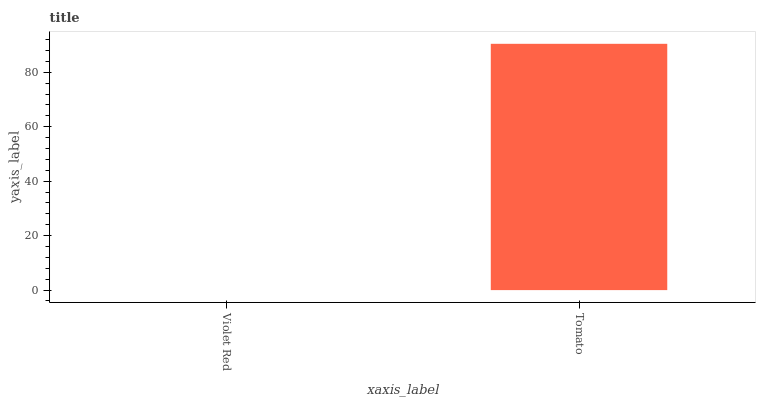Is Violet Red the minimum?
Answer yes or no. Yes. Is Tomato the maximum?
Answer yes or no. Yes. Is Tomato the minimum?
Answer yes or no. No. Is Tomato greater than Violet Red?
Answer yes or no. Yes. Is Violet Red less than Tomato?
Answer yes or no. Yes. Is Violet Red greater than Tomato?
Answer yes or no. No. Is Tomato less than Violet Red?
Answer yes or no. No. Is Tomato the high median?
Answer yes or no. Yes. Is Violet Red the low median?
Answer yes or no. Yes. Is Violet Red the high median?
Answer yes or no. No. Is Tomato the low median?
Answer yes or no. No. 